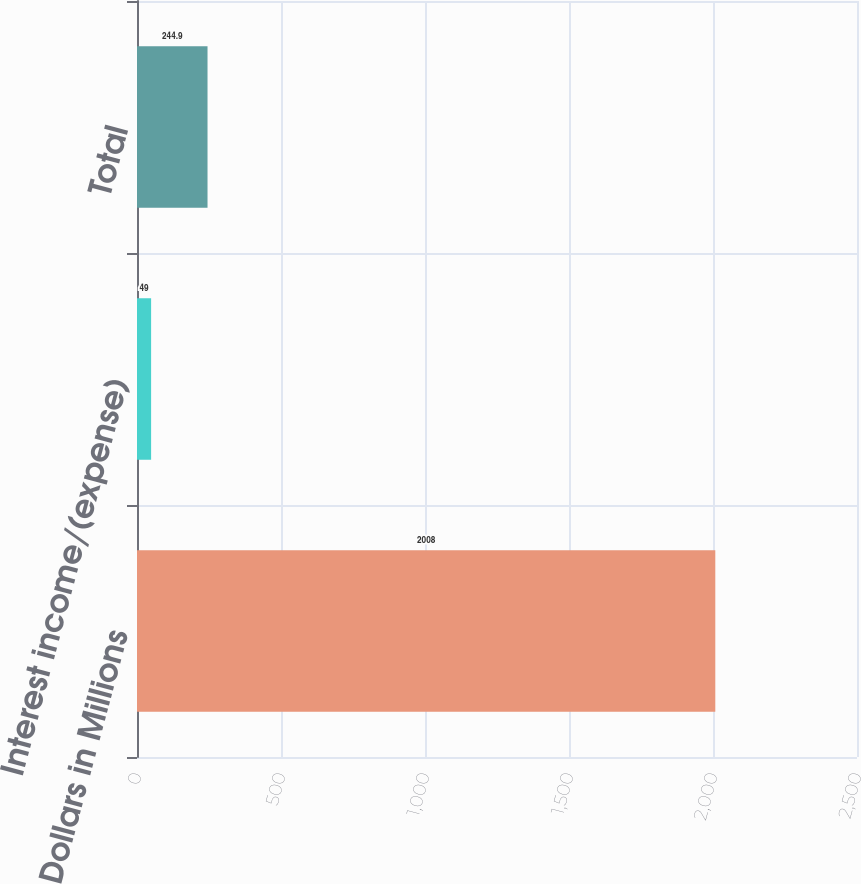<chart> <loc_0><loc_0><loc_500><loc_500><bar_chart><fcel>Dollars in Millions<fcel>Interest income/(expense)<fcel>Total<nl><fcel>2008<fcel>49<fcel>244.9<nl></chart> 